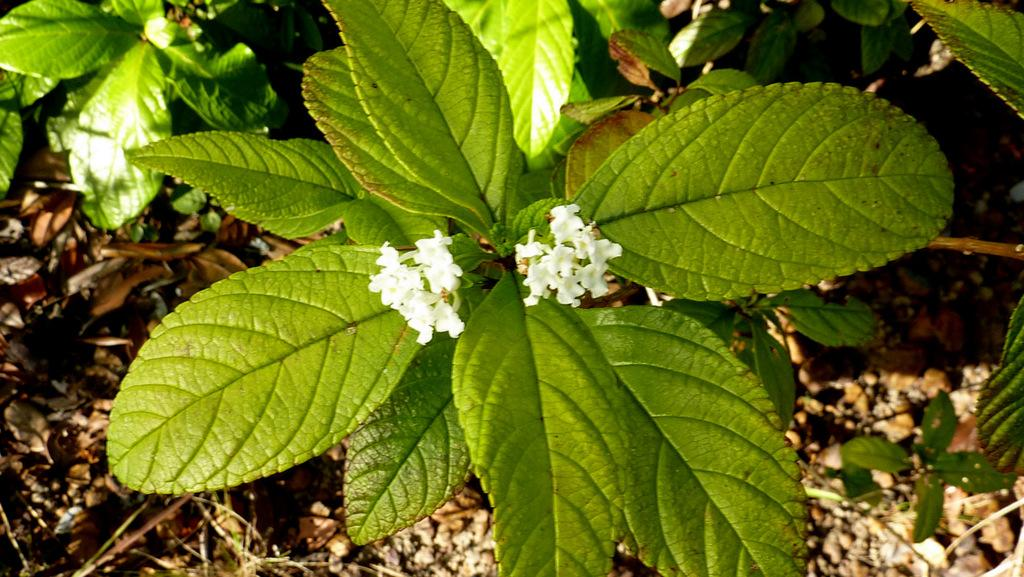What is present in the image? There is a plant in the image. What can be observed about the plant's flowers? The plant has tiny white flowers. What else can be seen in the background of the image? There are leaves in the background of the image. What type of polish is being applied to the plant's leaves in the image? There is no polish being applied to the plant's leaves in the image; the image only shows the plant with tiny white flowers and leaves in the background. 